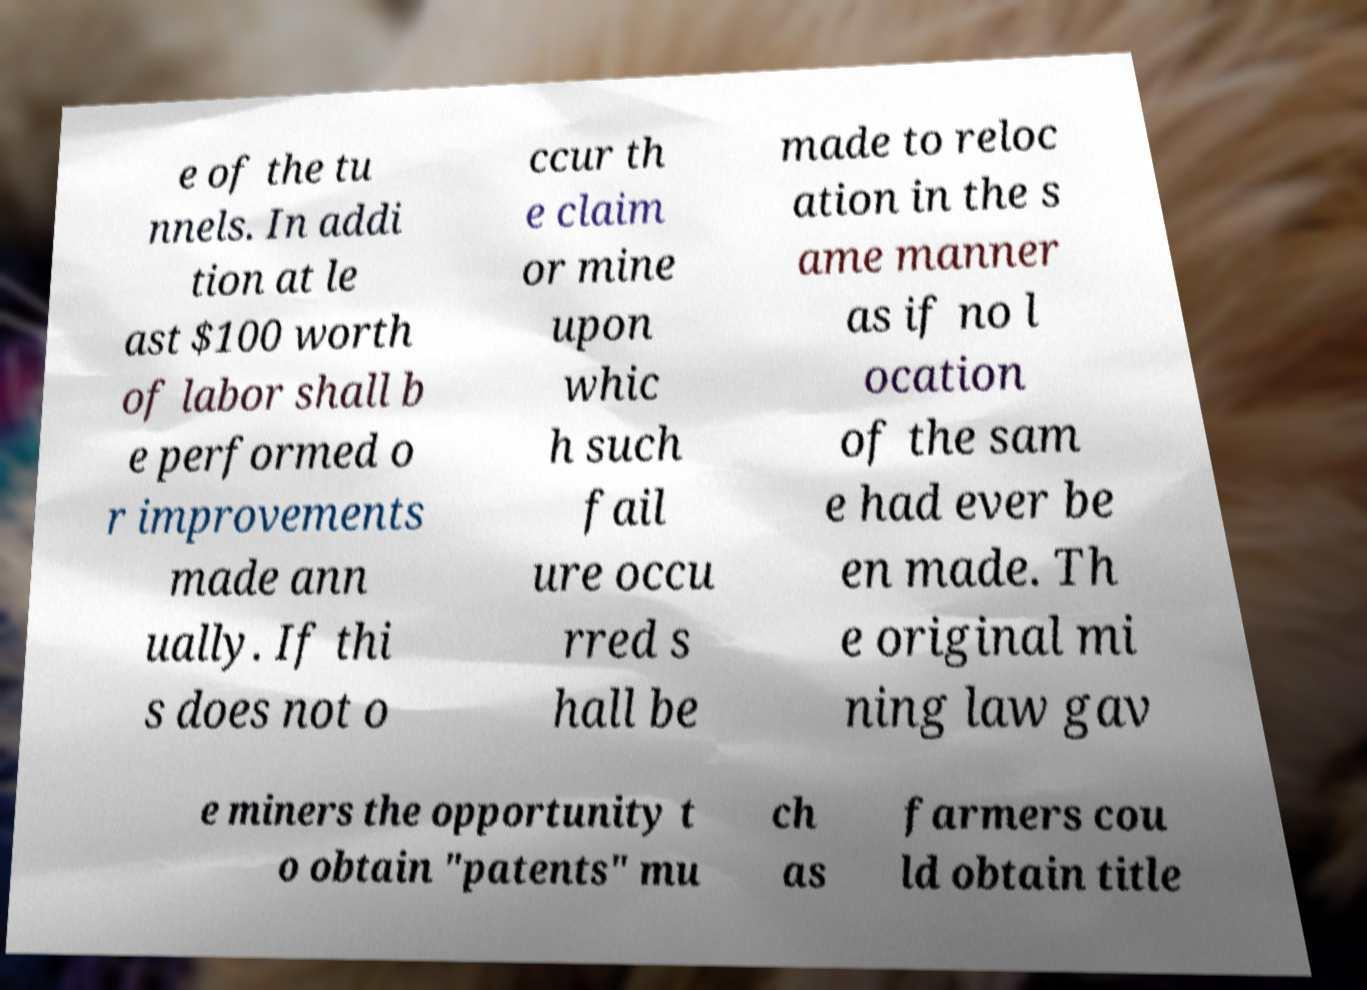What messages or text are displayed in this image? I need them in a readable, typed format. e of the tu nnels. In addi tion at le ast $100 worth of labor shall b e performed o r improvements made ann ually. If thi s does not o ccur th e claim or mine upon whic h such fail ure occu rred s hall be made to reloc ation in the s ame manner as if no l ocation of the sam e had ever be en made. Th e original mi ning law gav e miners the opportunity t o obtain "patents" mu ch as farmers cou ld obtain title 